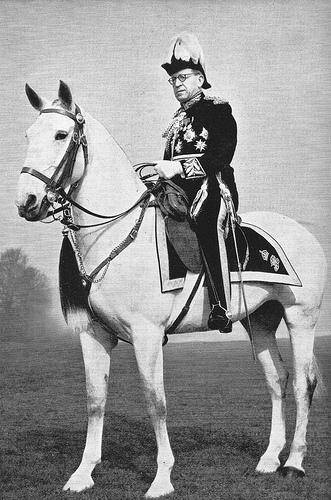Describe the main subject's attire and appearance. The man on the horse is wearing a military hat, glasses, a black and white uniform with stars, and shoes. Narrate the interactions between the man and the horse in the image. The man is sitting comfortably on the saddle, holding the horse's strap with his gloved hand and guiding its movement. Describe the objects near the ground and their connection to the main subjects. There is a shadow on the grass near the horse's legs, which belongs to the man in uniform riding the horse. Briefly describe the overall colors and style of the image. The picture is black and white, depicting a military man and a white horse in an old-fashioned setting. Point out the notable features of the horse. The white horse has black hooves, a strapped mouth, and a blanket with an emblem on its back. Identify the main subject and the environment they are situated in. A man in uniform is riding a white horse on a grassy area, with a tree and shadow on the ground nearby. Mention the three most important objects in the image. The man in uniform, the white horse, and the grassy area with a tree. Explain the position of the man and his interaction with the horse. The man is sitting on the saddle of the white horse, controlling it with a strap around its mouth. Provide a brief overview of the main elements in the picture. A military man wearing glasses and a hat is sitting on a white horse, surrounded by grass and a tree, with various elements like a saber, emblem, and straps visible. Mention the most prominent feature of the image with its color and location. A man in a black and white uniform riding a white horse in the center of the image. 